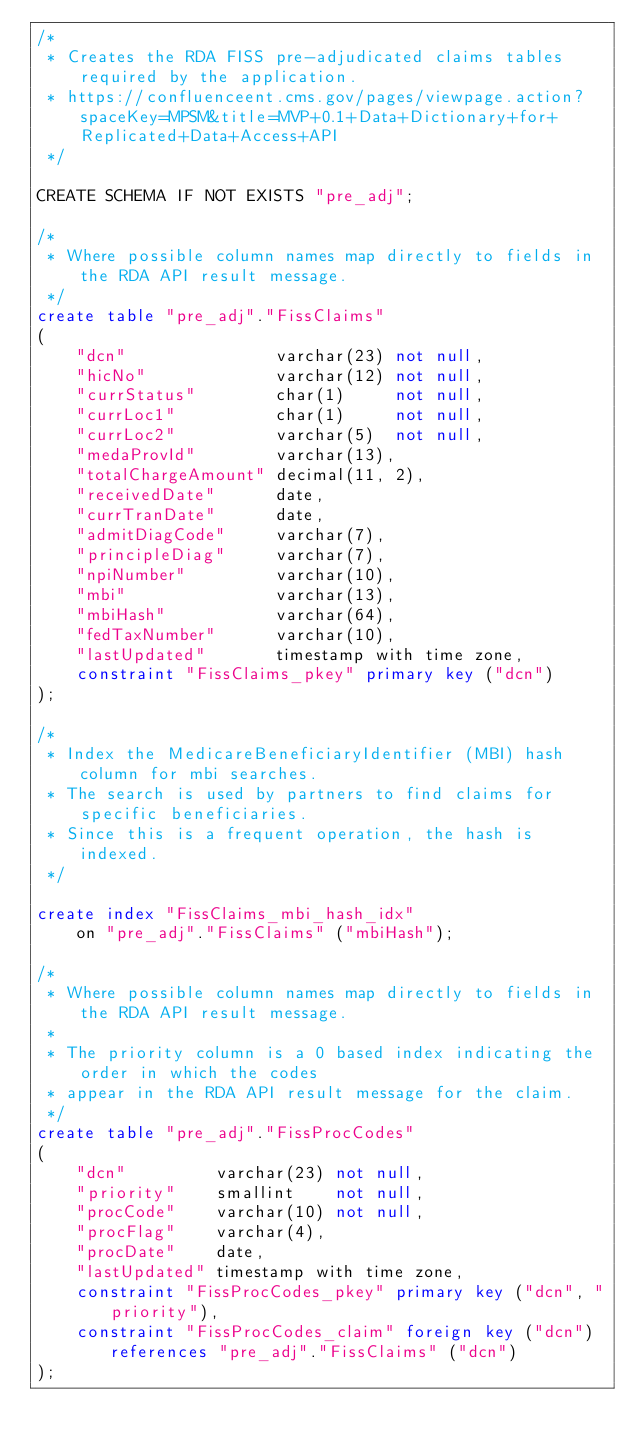<code> <loc_0><loc_0><loc_500><loc_500><_SQL_>/*
 * Creates the RDA FISS pre-adjudicated claims tables required by the application.
 * https://confluenceent.cms.gov/pages/viewpage.action?spaceKey=MPSM&title=MVP+0.1+Data+Dictionary+for+Replicated+Data+Access+API
 */

CREATE SCHEMA IF NOT EXISTS "pre_adj";

/*
 * Where possible column names map directly to fields in the RDA API result message.
 */
create table "pre_adj"."FissClaims"
(
    "dcn"               varchar(23) not null,
    "hicNo"             varchar(12) not null,
    "currStatus"        char(1)     not null,
    "currLoc1"          char(1)     not null,
    "currLoc2"          varchar(5)  not null,
    "medaProvId"        varchar(13),
    "totalChargeAmount" decimal(11, 2),
    "receivedDate"      date,
    "currTranDate"      date,
    "admitDiagCode"     varchar(7),
    "principleDiag"     varchar(7),
    "npiNumber"         varchar(10),
    "mbi"               varchar(13),
    "mbiHash"           varchar(64),
    "fedTaxNumber"      varchar(10),
    "lastUpdated"       timestamp with time zone,
    constraint "FissClaims_pkey" primary key ("dcn")
);

/*
 * Index the MedicareBeneficiaryIdentifier (MBI) hash column for mbi searches.
 * The search is used by partners to find claims for specific beneficiaries.
 * Since this is a frequent operation, the hash is indexed.
 */

create index "FissClaims_mbi_hash_idx"
    on "pre_adj"."FissClaims" ("mbiHash");

/*
 * Where possible column names map directly to fields in the RDA API result message.
 *
 * The priority column is a 0 based index indicating the order in which the codes
 * appear in the RDA API result message for the claim.
 */
create table "pre_adj"."FissProcCodes"
(
    "dcn"         varchar(23) not null,
    "priority"    smallint    not null,
    "procCode"    varchar(10) not null,
    "procFlag"    varchar(4),
    "procDate"    date,
    "lastUpdated" timestamp with time zone,
    constraint "FissProcCodes_pkey" primary key ("dcn", "priority"),
    constraint "FissProcCodes_claim" foreign key ("dcn") references "pre_adj"."FissClaims" ("dcn")
);
</code> 